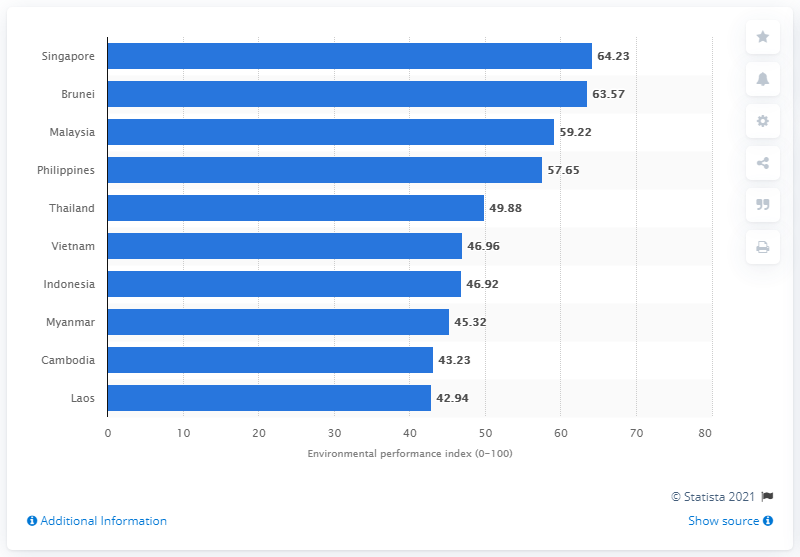Mention a couple of crucial points in this snapshot. In 2018, Singapore's Economic Performance Index (EPI) was 63.57. In 2018, Malaysia's EPI was 59.22. The EPI (Economic Planning and Investment) of the Philippines in 2018 was 57.65. 